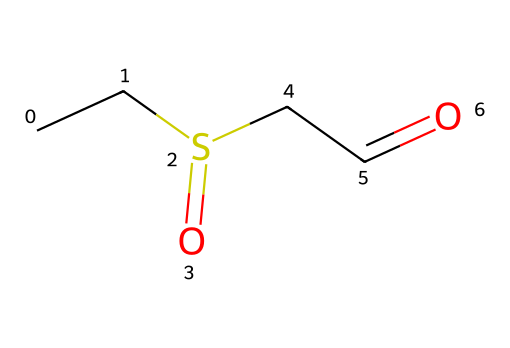What is the molecular formula of this compound? The SMILES representation indicates the presence of carbon (C), sulfur (S), and oxygen (O) atoms. Counting the atoms from the structure, we find that there are four carbon atoms, two oxygen atoms, and one sulfur atom, leading to the molecular formula C4H8O2S.
Answer: C4H8O2S How many functional groups are present in this compound? Analyzing the structure reveals that there are two distinct functional groups: a thioether (due to the sulfur atom connected to a carbon chain) and an aldehyde (due to the presence of the -CHO group), resulting in a total of two functional groups in the molecule.
Answer: two What type of isomerism is exhibited by this compound? The compound has a defined structure (not containing any geometrical or optical isomers), meaning it primarily exists as a singular structure without any isomeric forms associated with it, indicating it does not exhibit significant isomerism.
Answer: structural Which atom in the compound contributes to the sulfurous notes in cheeses? The structure shows the presence of a sulfur atom (the 'S' in the SMILES) that significantly influences the compound's aroma profile, contributing to the noted sulfurous aromas in various cheeses.
Answer: sulfur How many hydrogen atoms are in this compound? Counting the hydrogen atoms from the molecular structure, we see that there are eight hydrogen atoms connected to the carbon backbone, leading to the conclusion that the molecule contains eight hydrogen atoms overall.
Answer: eight What type of compound is represented by this SMILES structure? Given that the structure contains a sulfur atom and the characteristic aldehyde functional group, it is identified as a thioaldehyde, which falls under the broader category of organic sulfur compounds.
Answer: thioaldehyde 